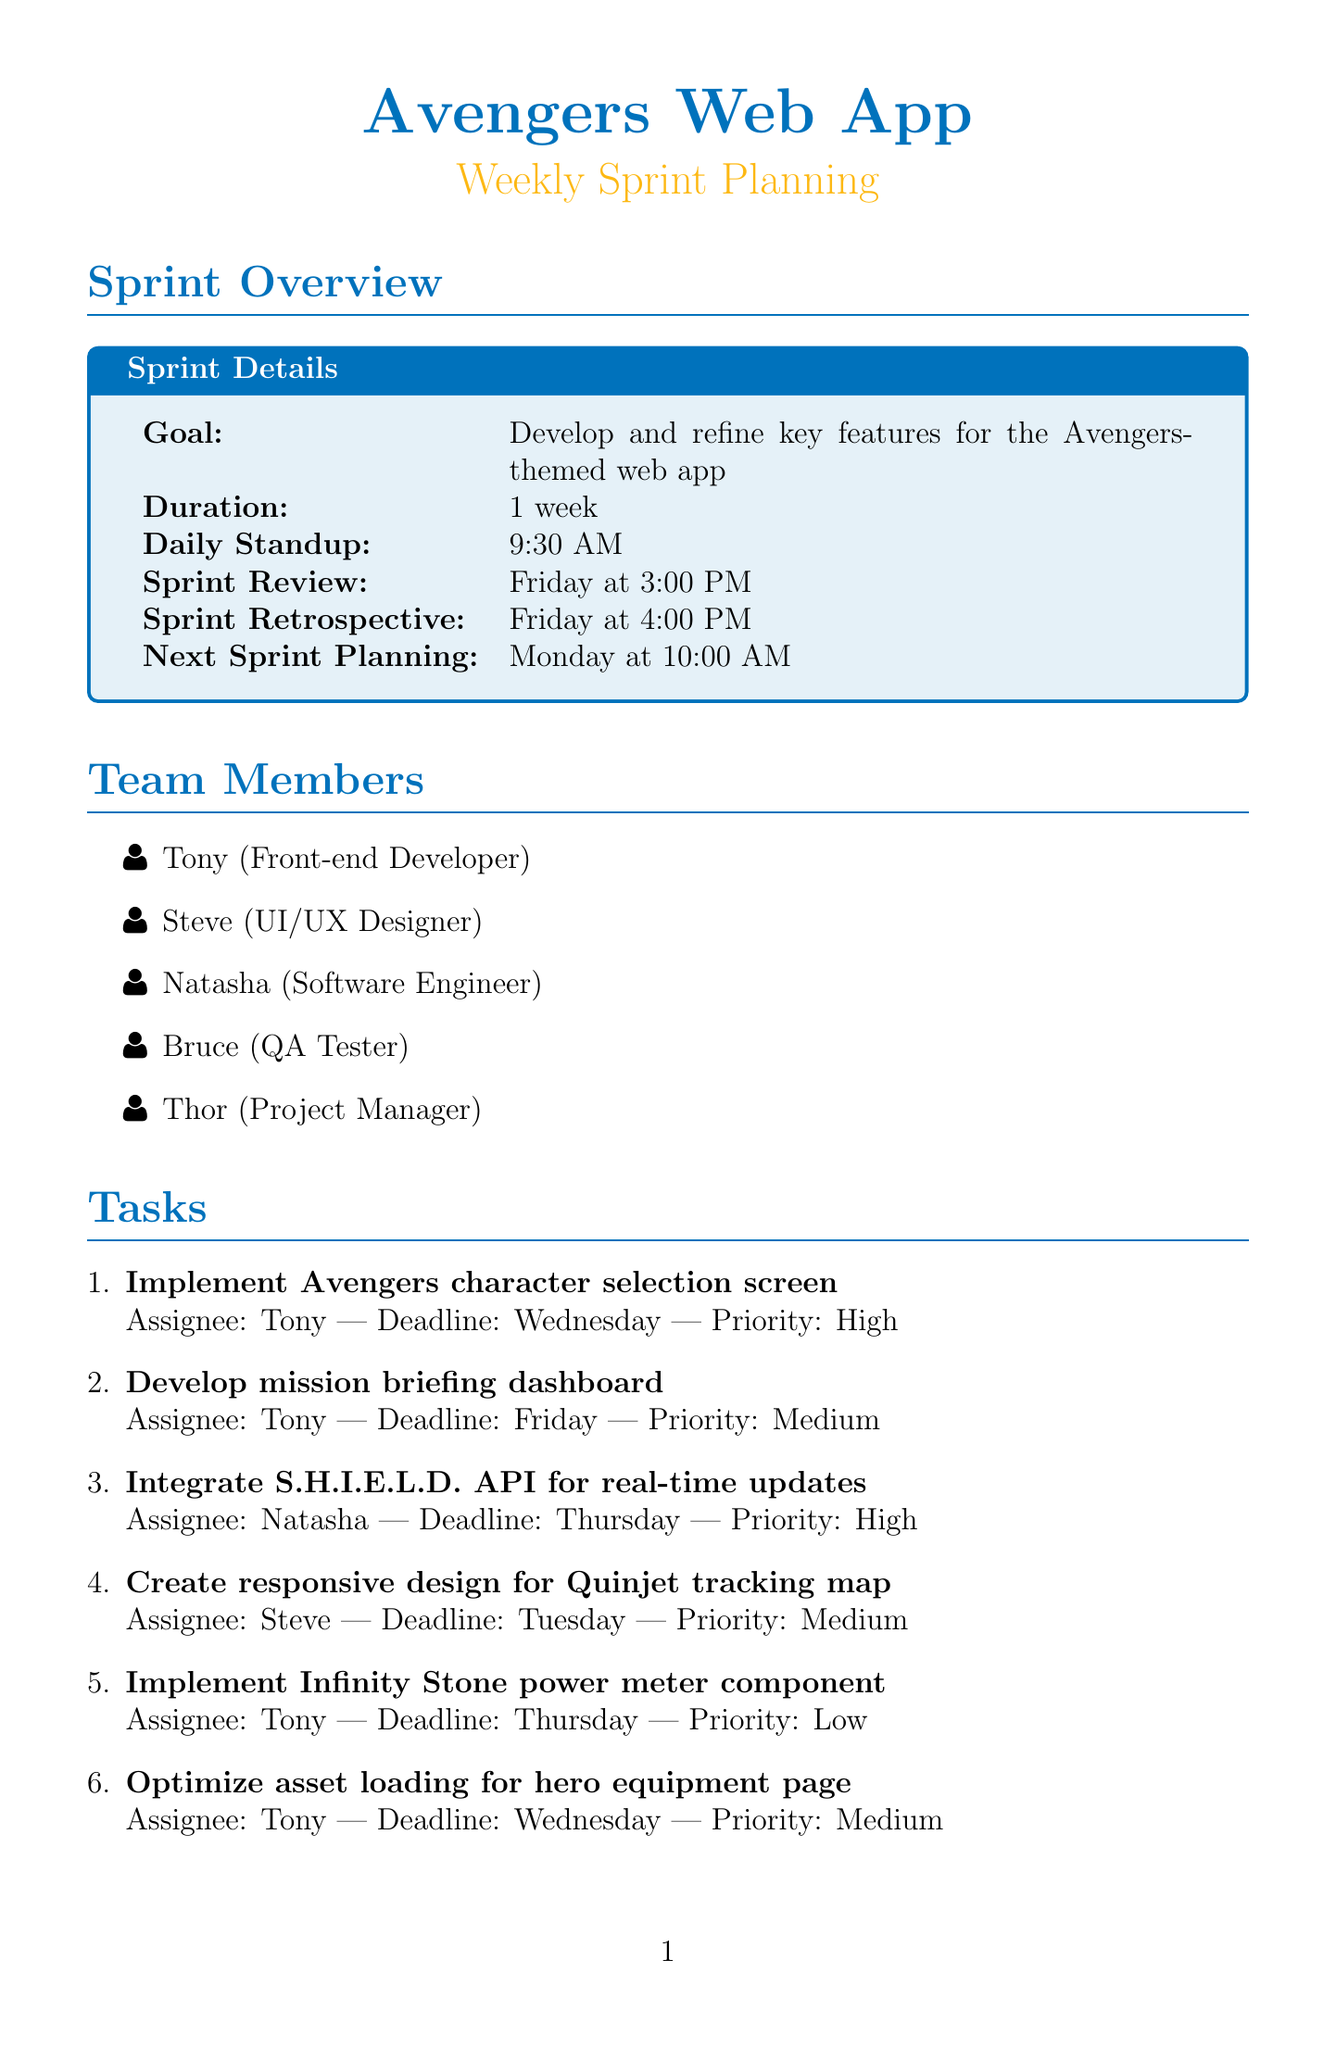what is the sprint goal? The sprint goal is stated in the document as the objective for the team during the sprint period.
Answer: Develop and refine key features for the Avengers-themed web app who is assigned to implement the character selection screen? The document specifies the assignee for each task, including the character selection screen.
Answer: Tony what is the deadline for the mission briefing dashboard? The deadline for each task is listed in the document for reference.
Answer: Friday which team member is responsible for unit tests? Each task has a designated assignee, and this information can be found under the tasks section.
Answer: Bruce what time is the daily standup scheduled? The document provides the scheduled time for daily standups, which is consistent throughout the sprint.
Answer: 9:30 AM how many tasks are assigned to Tony? The information about the number of tasks assigned to each team member can be counted from the tasks section.
Answer: 5 when is the sprint review date? The document specifies the date and time for the review, which is a key event in sprint planning.
Answer: Friday at 3:00 PM what is the priority of the Thanos threat level calculator task? Each task in the document is assigned a priority, reflecting its importance within the sprint schedule.
Answer: High which designer is responsible for the Quinjet tracking map? The document delineates the roles and responsibilities in the team, including design tasks.
Answer: Steve 